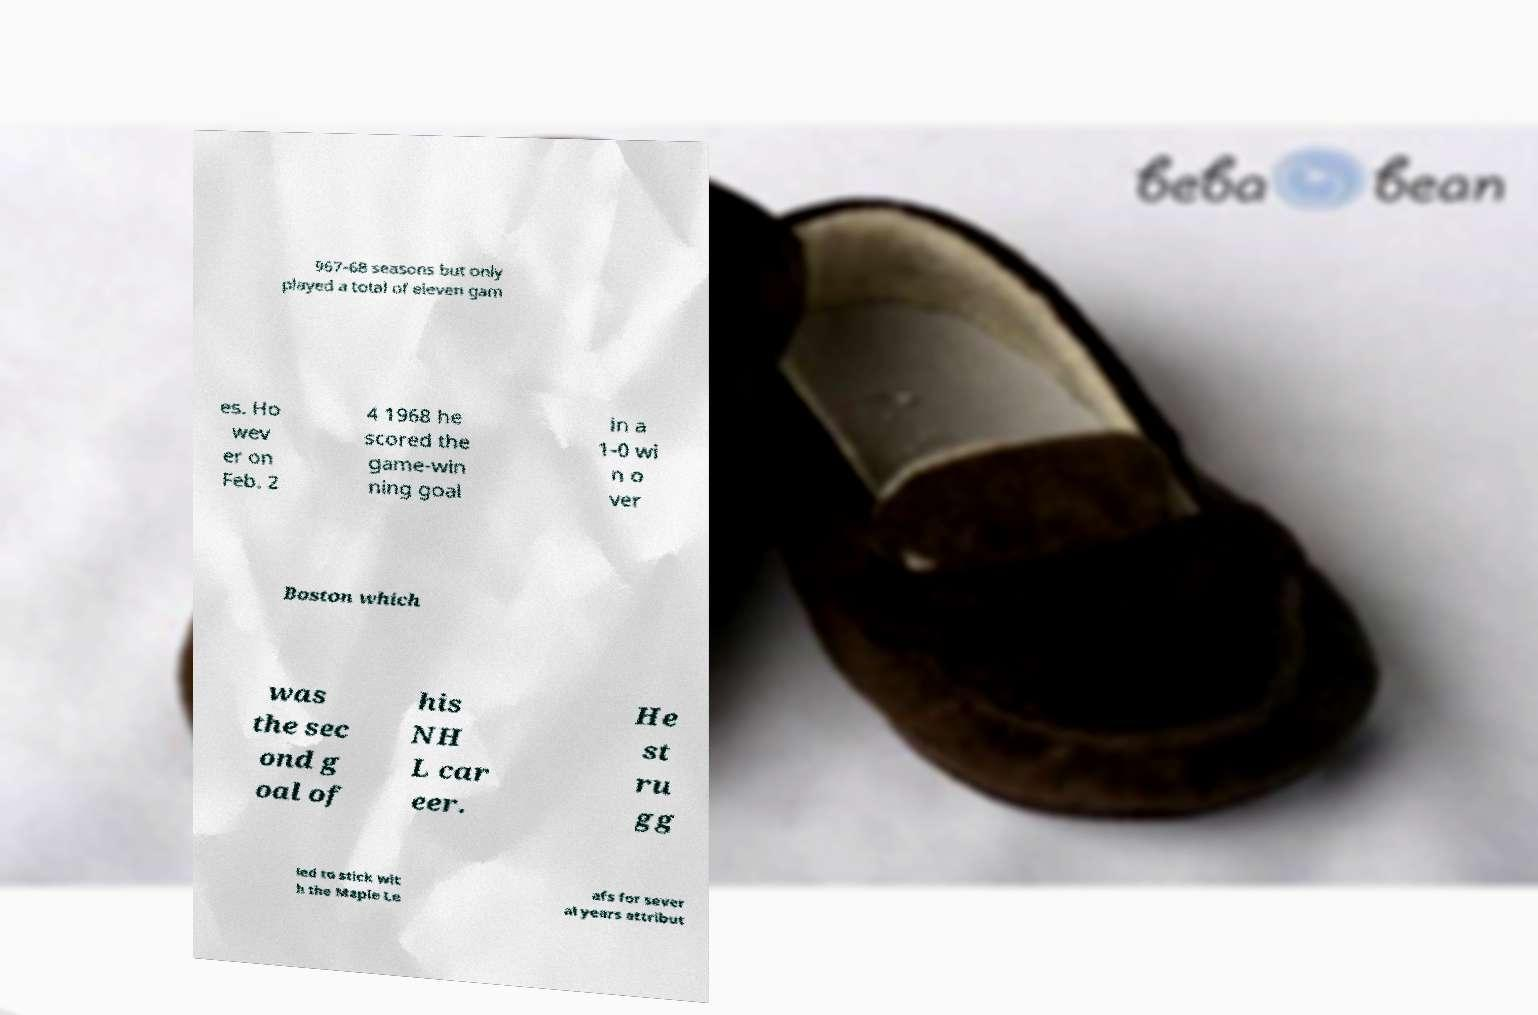There's text embedded in this image that I need extracted. Can you transcribe it verbatim? 967-68 seasons but only played a total of eleven gam es. Ho wev er on Feb. 2 4 1968 he scored the game-win ning goal in a 1-0 wi n o ver Boston which was the sec ond g oal of his NH L car eer. He st ru gg led to stick wit h the Maple Le afs for sever al years attribut 